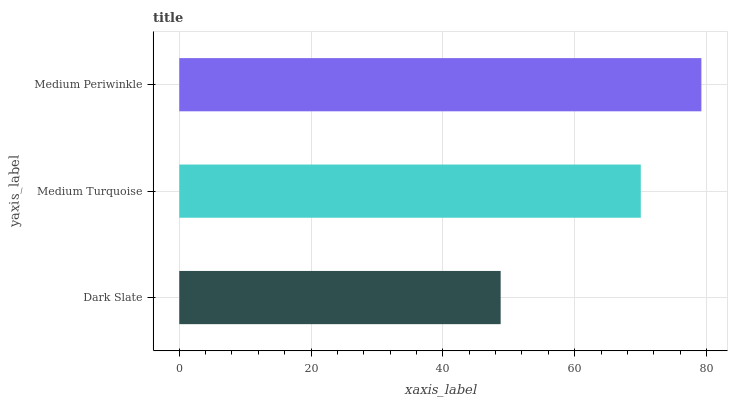Is Dark Slate the minimum?
Answer yes or no. Yes. Is Medium Periwinkle the maximum?
Answer yes or no. Yes. Is Medium Turquoise the minimum?
Answer yes or no. No. Is Medium Turquoise the maximum?
Answer yes or no. No. Is Medium Turquoise greater than Dark Slate?
Answer yes or no. Yes. Is Dark Slate less than Medium Turquoise?
Answer yes or no. Yes. Is Dark Slate greater than Medium Turquoise?
Answer yes or no. No. Is Medium Turquoise less than Dark Slate?
Answer yes or no. No. Is Medium Turquoise the high median?
Answer yes or no. Yes. Is Medium Turquoise the low median?
Answer yes or no. Yes. Is Dark Slate the high median?
Answer yes or no. No. Is Medium Periwinkle the low median?
Answer yes or no. No. 